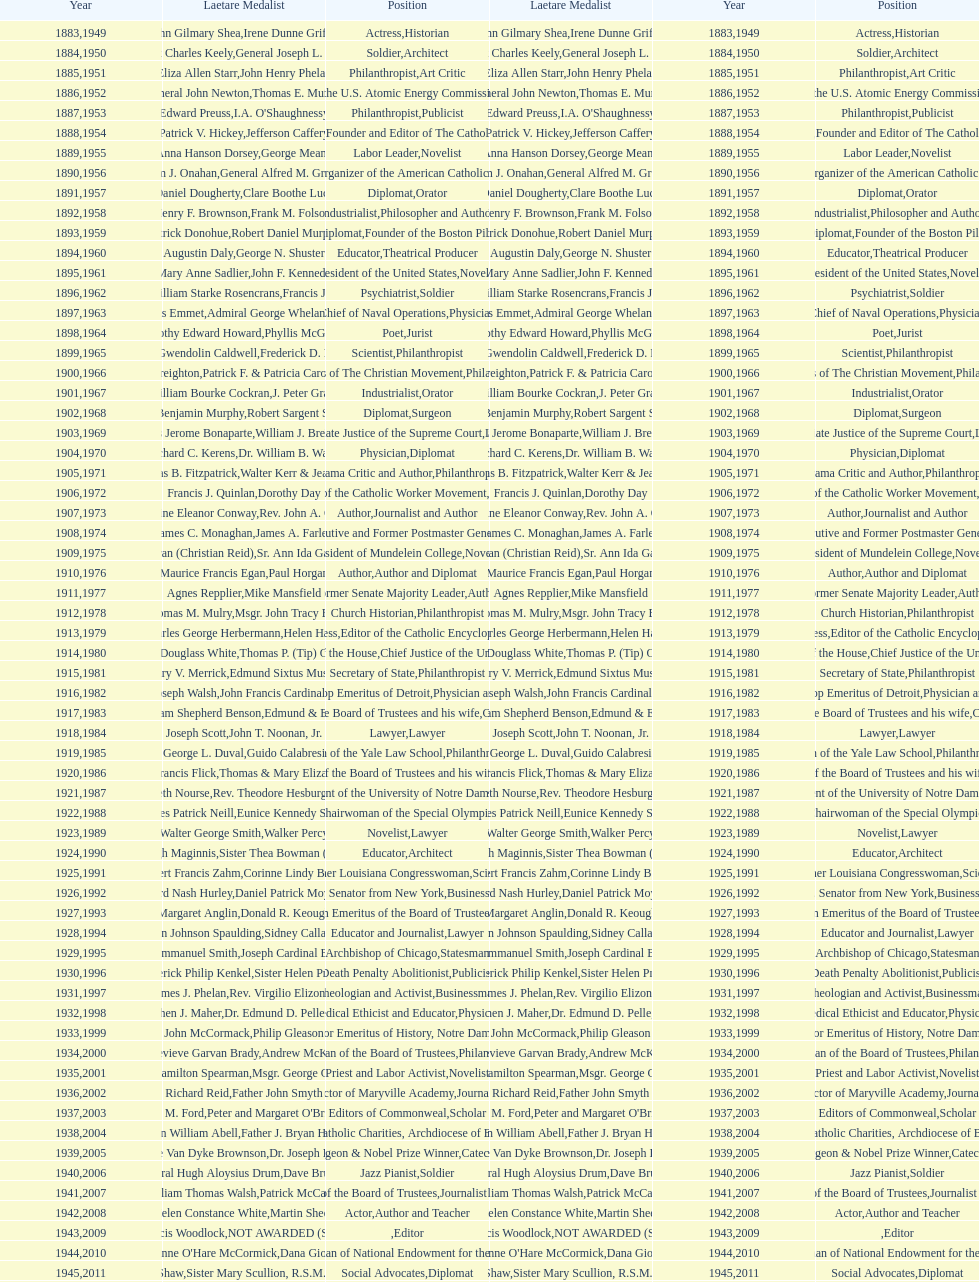How many are or were journalists? 5. 